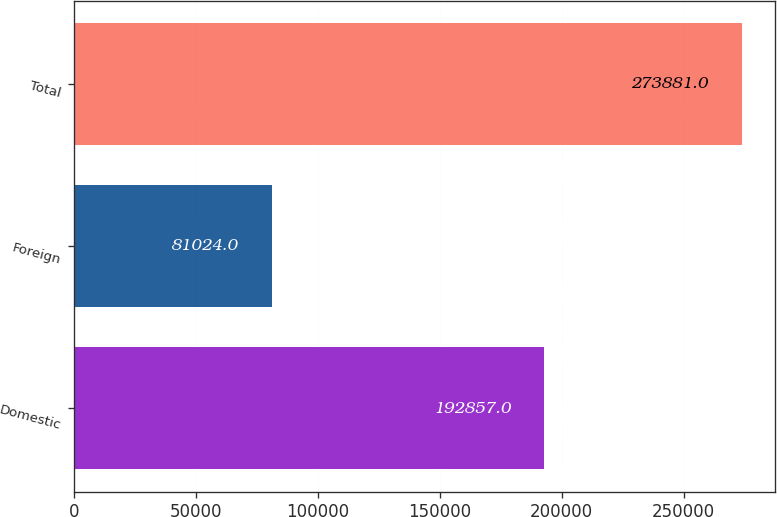Convert chart to OTSL. <chart><loc_0><loc_0><loc_500><loc_500><bar_chart><fcel>Domestic<fcel>Foreign<fcel>Total<nl><fcel>192857<fcel>81024<fcel>273881<nl></chart> 